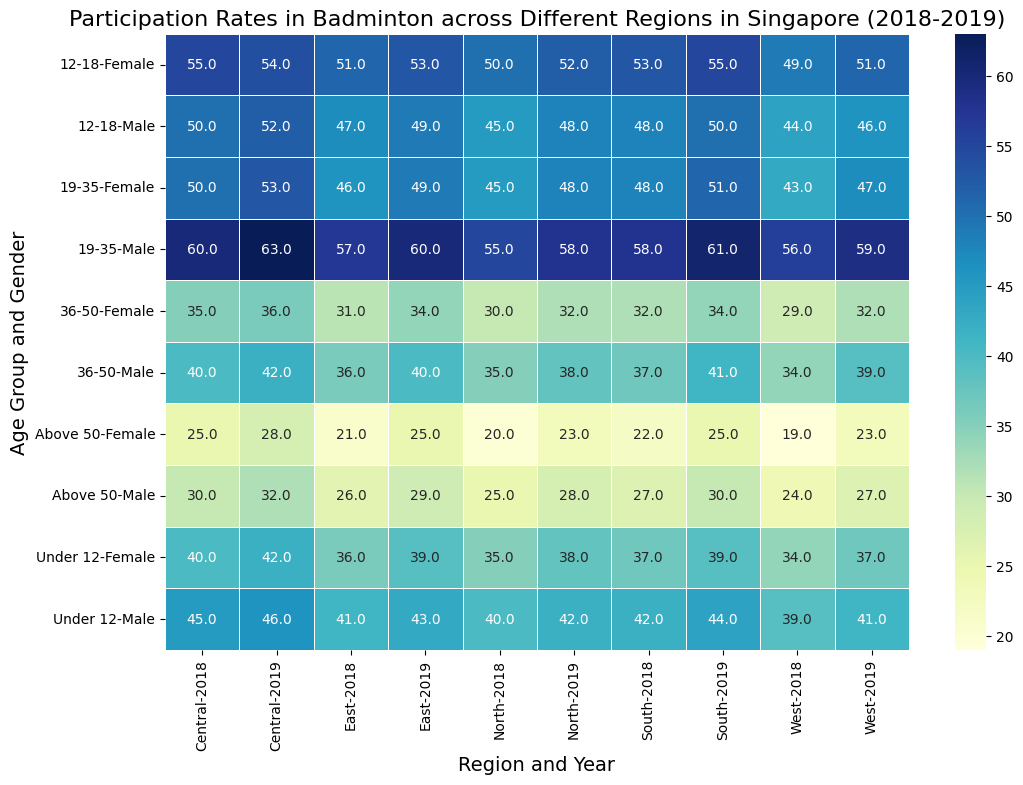Which region had the highest participation rate for males aged 19-35 in 2019? Look at the heatmap, locate the 19-35 age group and male gender row, and find the highest value among the regions for the year 2019. The South region shows a participation rate of 61.
Answer: South Did the female participation rate for the Under 12 age group increase or decrease in the Central region from 2018 to 2019? Compare the participation rates for females under 12 in the Central region between the years 2018 and 2019. The value increased from 40 to 42 from 2018 to 2019.
Answer: Increase Which age group showed the highest participation rate in the North region for females in 2019? Find the North region for the year 2019, then look at the columns for female participants. The 12-18 age group shows the highest participation rate of 52.
Answer: 12-18 What's the overall participation rate difference between males aged 36-50 and above 50 in the West region for the year 2019? Locate the West region for 2019 and subtract the participation rate of males aged above 50 from the participation rate of males aged 36-50 (39 - 27). The difference is 12.
Answer: 12 Which gender had a higher average participation rate in the East region across all age groups in 2018? Calculate the average participation rate for both genders across all age groups in the East region for 2018. For males: (41 + 47 + 57 + 36 + 26) / 5 = 41.4. For females: (36 + 51 + 46 + 31 + 21) / 5 = 37. The average rate is higher for males.
Answer: Male 